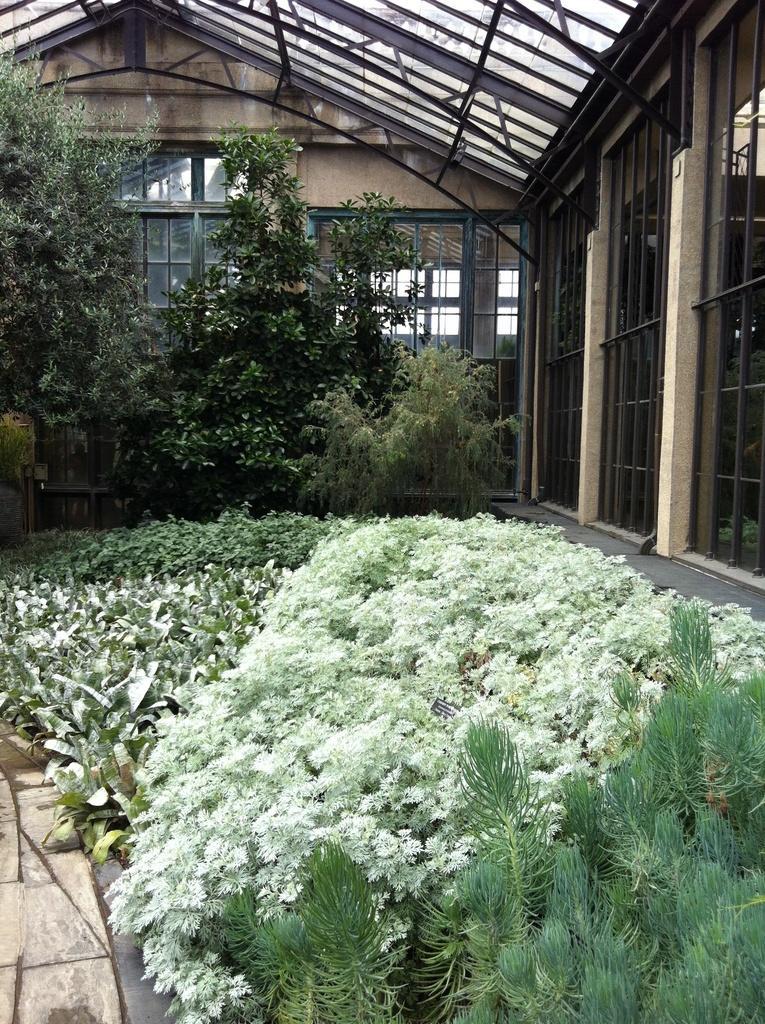Can you describe this image briefly? At the bottom of this image there are many plants. On the right side, I can see the glass. In the background there are some trees and a building. 